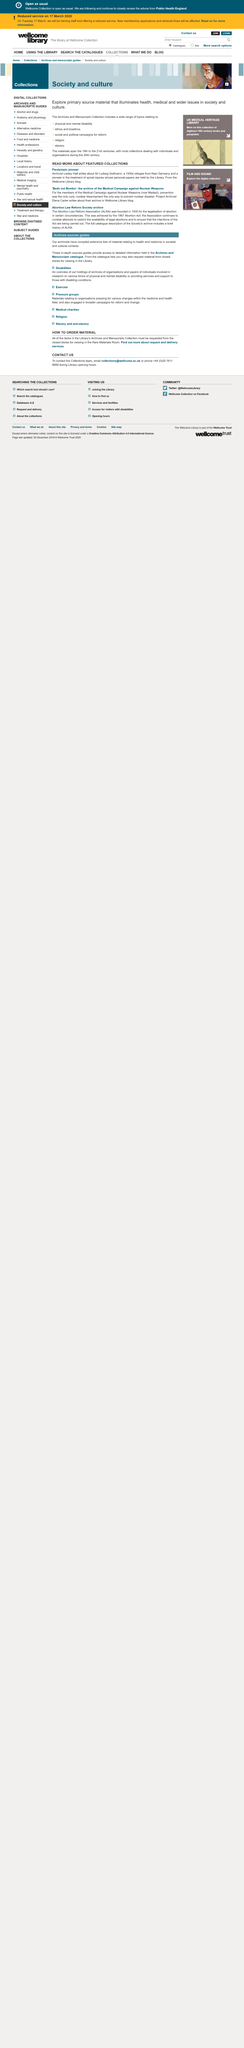Highlight a few significant elements in this photo. The archive written by Elena Carter is called "Beds not Bombs. In the 1930s, Sir Ludwig Guffmann was a refugee from Nazi Germany. Lesley Hall wrote about a Paralympic pioneer, who was also the subject of a book written by Sir Ludwig Guffmann. 